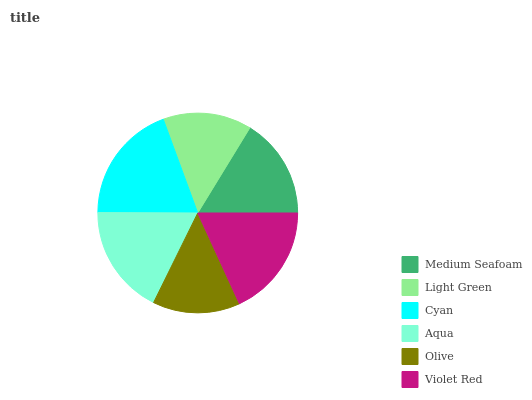Is Olive the minimum?
Answer yes or no. Yes. Is Cyan the maximum?
Answer yes or no. Yes. Is Light Green the minimum?
Answer yes or no. No. Is Light Green the maximum?
Answer yes or no. No. Is Medium Seafoam greater than Light Green?
Answer yes or no. Yes. Is Light Green less than Medium Seafoam?
Answer yes or no. Yes. Is Light Green greater than Medium Seafoam?
Answer yes or no. No. Is Medium Seafoam less than Light Green?
Answer yes or no. No. Is Aqua the high median?
Answer yes or no. Yes. Is Medium Seafoam the low median?
Answer yes or no. Yes. Is Medium Seafoam the high median?
Answer yes or no. No. Is Olive the low median?
Answer yes or no. No. 